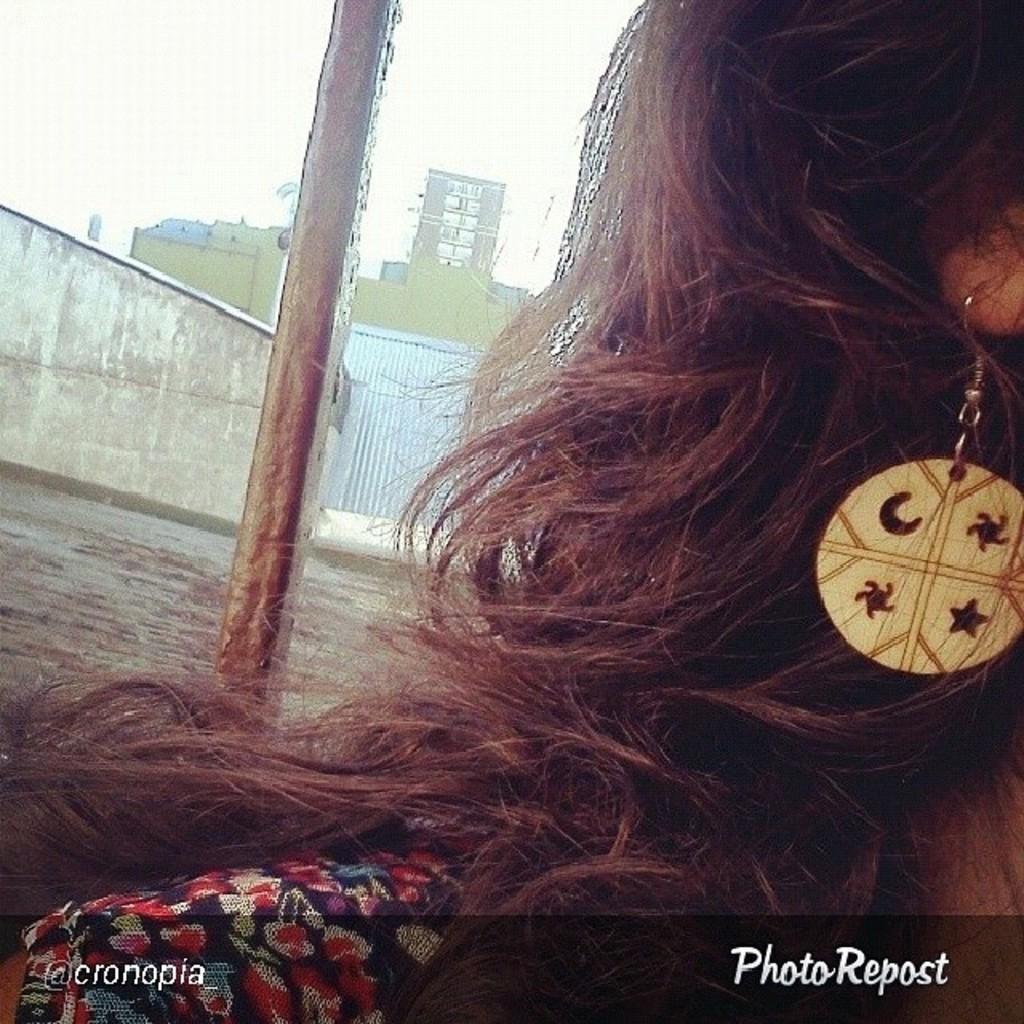In one or two sentences, can you explain what this image depicts? In this image we can see a woman wearing earrings. In the background, we can see a pole, group of buildings and the sky. At the bottom we can see some text. 